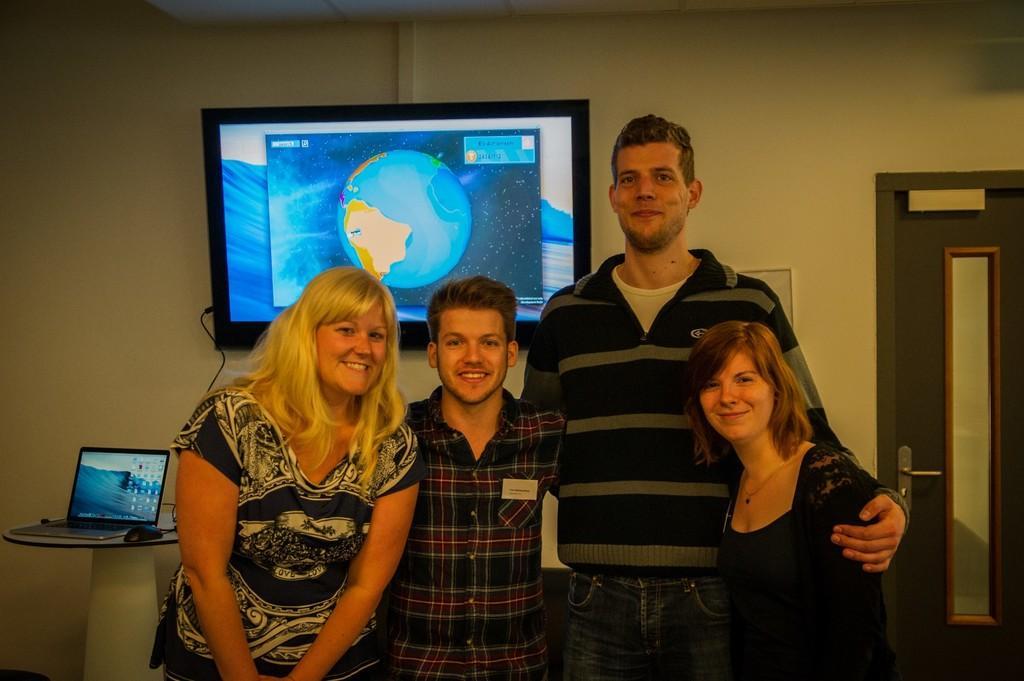Can you describe this image briefly? In this image we can see a group of people standing. On the backside we can see a laptop and a mouse on a table, a television on a wall and a door. 